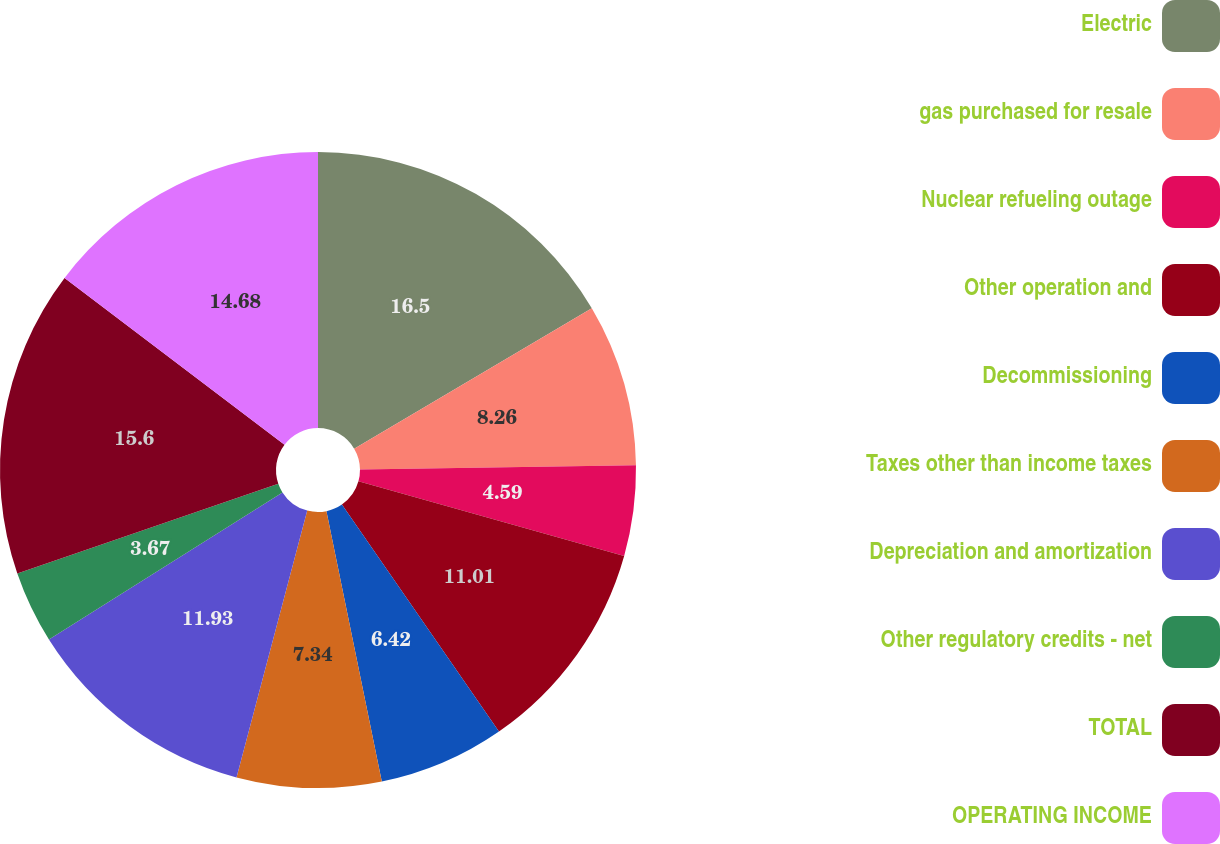Convert chart. <chart><loc_0><loc_0><loc_500><loc_500><pie_chart><fcel>Electric<fcel>gas purchased for resale<fcel>Nuclear refueling outage<fcel>Other operation and<fcel>Decommissioning<fcel>Taxes other than income taxes<fcel>Depreciation and amortization<fcel>Other regulatory credits - net<fcel>TOTAL<fcel>OPERATING INCOME<nl><fcel>16.51%<fcel>8.26%<fcel>4.59%<fcel>11.01%<fcel>6.42%<fcel>7.34%<fcel>11.93%<fcel>3.67%<fcel>15.6%<fcel>14.68%<nl></chart> 